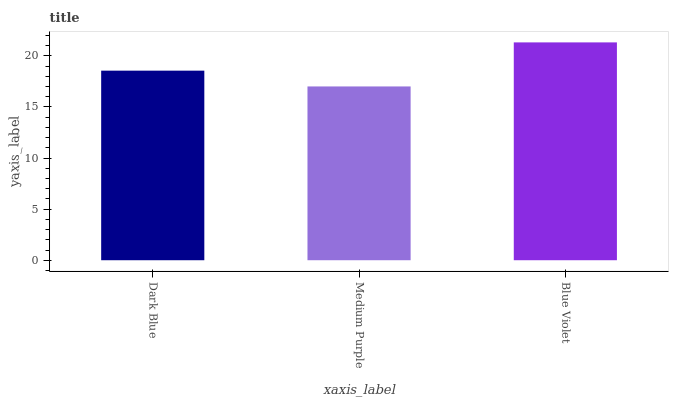Is Medium Purple the minimum?
Answer yes or no. Yes. Is Blue Violet the maximum?
Answer yes or no. Yes. Is Blue Violet the minimum?
Answer yes or no. No. Is Medium Purple the maximum?
Answer yes or no. No. Is Blue Violet greater than Medium Purple?
Answer yes or no. Yes. Is Medium Purple less than Blue Violet?
Answer yes or no. Yes. Is Medium Purple greater than Blue Violet?
Answer yes or no. No. Is Blue Violet less than Medium Purple?
Answer yes or no. No. Is Dark Blue the high median?
Answer yes or no. Yes. Is Dark Blue the low median?
Answer yes or no. Yes. Is Medium Purple the high median?
Answer yes or no. No. Is Medium Purple the low median?
Answer yes or no. No. 